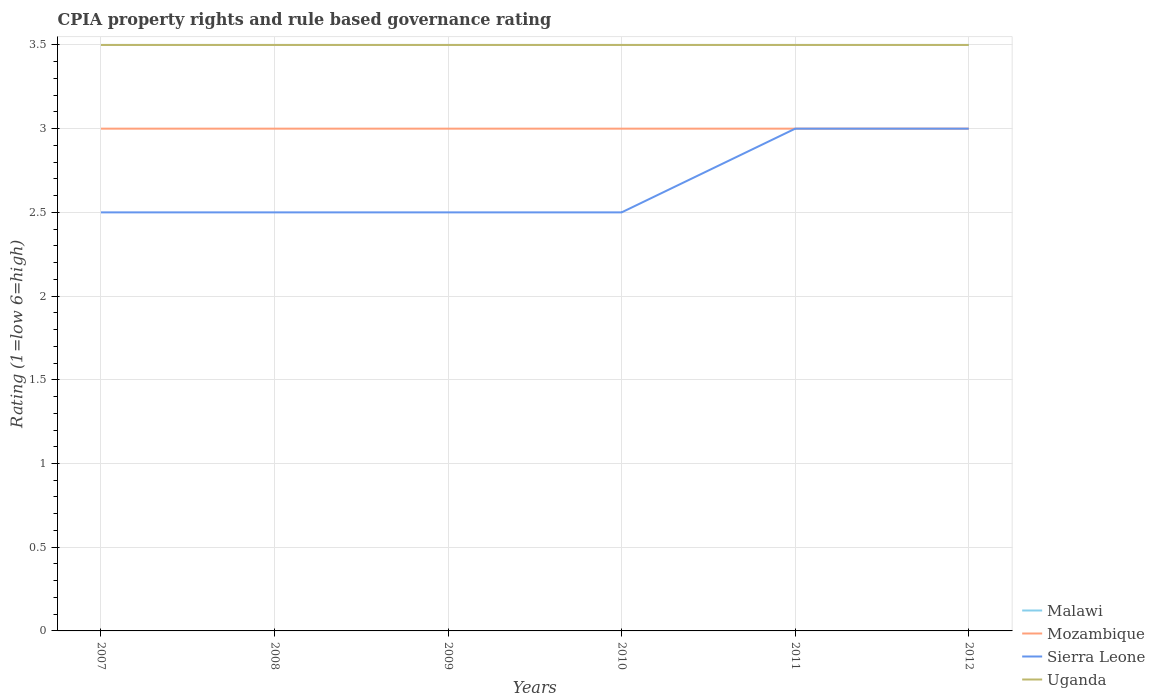Is the number of lines equal to the number of legend labels?
Your answer should be very brief. Yes. Across all years, what is the maximum CPIA rating in Sierra Leone?
Keep it short and to the point. 2.5. In which year was the CPIA rating in Malawi maximum?
Offer a very short reply. 2007. What is the total CPIA rating in Mozambique in the graph?
Give a very brief answer. 0. What is the difference between the highest and the second highest CPIA rating in Uganda?
Offer a very short reply. 0. What is the difference between the highest and the lowest CPIA rating in Mozambique?
Your answer should be compact. 0. Is the CPIA rating in Malawi strictly greater than the CPIA rating in Uganda over the years?
Give a very brief answer. No. What is the difference between two consecutive major ticks on the Y-axis?
Provide a succinct answer. 0.5. Are the values on the major ticks of Y-axis written in scientific E-notation?
Offer a very short reply. No. How many legend labels are there?
Your response must be concise. 4. How are the legend labels stacked?
Keep it short and to the point. Vertical. What is the title of the graph?
Ensure brevity in your answer.  CPIA property rights and rule based governance rating. What is the label or title of the Y-axis?
Ensure brevity in your answer.  Rating (1=low 6=high). What is the Rating (1=low 6=high) in Mozambique in 2007?
Make the answer very short. 3. What is the Rating (1=low 6=high) in Sierra Leone in 2008?
Make the answer very short. 2.5. What is the Rating (1=low 6=high) in Uganda in 2008?
Your response must be concise. 3.5. What is the Rating (1=low 6=high) of Uganda in 2010?
Your answer should be very brief. 3.5. What is the Rating (1=low 6=high) in Malawi in 2012?
Offer a very short reply. 3.5. What is the Rating (1=low 6=high) of Mozambique in 2012?
Your answer should be compact. 3. What is the Rating (1=low 6=high) of Sierra Leone in 2012?
Give a very brief answer. 3. Across all years, what is the maximum Rating (1=low 6=high) of Malawi?
Ensure brevity in your answer.  3.5. Across all years, what is the maximum Rating (1=low 6=high) of Uganda?
Provide a succinct answer. 3.5. Across all years, what is the minimum Rating (1=low 6=high) in Mozambique?
Give a very brief answer. 3. What is the total Rating (1=low 6=high) of Malawi in the graph?
Offer a very short reply. 21. What is the total Rating (1=low 6=high) in Mozambique in the graph?
Provide a short and direct response. 18. What is the total Rating (1=low 6=high) in Sierra Leone in the graph?
Ensure brevity in your answer.  16. What is the difference between the Rating (1=low 6=high) of Malawi in 2007 and that in 2008?
Provide a short and direct response. 0. What is the difference between the Rating (1=low 6=high) in Mozambique in 2007 and that in 2008?
Offer a terse response. 0. What is the difference between the Rating (1=low 6=high) in Malawi in 2007 and that in 2009?
Your answer should be compact. 0. What is the difference between the Rating (1=low 6=high) of Mozambique in 2007 and that in 2009?
Provide a short and direct response. 0. What is the difference between the Rating (1=low 6=high) of Uganda in 2007 and that in 2009?
Your answer should be very brief. 0. What is the difference between the Rating (1=low 6=high) of Malawi in 2007 and that in 2010?
Ensure brevity in your answer.  0. What is the difference between the Rating (1=low 6=high) of Mozambique in 2007 and that in 2010?
Provide a short and direct response. 0. What is the difference between the Rating (1=low 6=high) in Sierra Leone in 2007 and that in 2010?
Keep it short and to the point. 0. What is the difference between the Rating (1=low 6=high) of Malawi in 2007 and that in 2011?
Provide a short and direct response. 0. What is the difference between the Rating (1=low 6=high) of Mozambique in 2007 and that in 2011?
Make the answer very short. 0. What is the difference between the Rating (1=low 6=high) in Sierra Leone in 2007 and that in 2011?
Your answer should be compact. -0.5. What is the difference between the Rating (1=low 6=high) in Uganda in 2007 and that in 2011?
Your answer should be very brief. 0. What is the difference between the Rating (1=low 6=high) of Malawi in 2007 and that in 2012?
Your response must be concise. 0. What is the difference between the Rating (1=low 6=high) of Mozambique in 2007 and that in 2012?
Your answer should be compact. 0. What is the difference between the Rating (1=low 6=high) of Uganda in 2007 and that in 2012?
Offer a very short reply. 0. What is the difference between the Rating (1=low 6=high) in Sierra Leone in 2008 and that in 2009?
Ensure brevity in your answer.  0. What is the difference between the Rating (1=low 6=high) in Mozambique in 2008 and that in 2010?
Offer a very short reply. 0. What is the difference between the Rating (1=low 6=high) of Sierra Leone in 2008 and that in 2010?
Provide a short and direct response. 0. What is the difference between the Rating (1=low 6=high) of Mozambique in 2008 and that in 2011?
Provide a succinct answer. 0. What is the difference between the Rating (1=low 6=high) in Malawi in 2008 and that in 2012?
Offer a terse response. 0. What is the difference between the Rating (1=low 6=high) in Uganda in 2009 and that in 2010?
Provide a succinct answer. 0. What is the difference between the Rating (1=low 6=high) of Malawi in 2009 and that in 2011?
Provide a succinct answer. 0. What is the difference between the Rating (1=low 6=high) of Sierra Leone in 2009 and that in 2011?
Your answer should be very brief. -0.5. What is the difference between the Rating (1=low 6=high) of Mozambique in 2009 and that in 2012?
Give a very brief answer. 0. What is the difference between the Rating (1=low 6=high) of Malawi in 2010 and that in 2011?
Keep it short and to the point. 0. What is the difference between the Rating (1=low 6=high) of Sierra Leone in 2010 and that in 2011?
Give a very brief answer. -0.5. What is the difference between the Rating (1=low 6=high) of Mozambique in 2010 and that in 2012?
Your response must be concise. 0. What is the difference between the Rating (1=low 6=high) of Uganda in 2010 and that in 2012?
Keep it short and to the point. 0. What is the difference between the Rating (1=low 6=high) in Malawi in 2011 and that in 2012?
Keep it short and to the point. 0. What is the difference between the Rating (1=low 6=high) of Sierra Leone in 2011 and that in 2012?
Ensure brevity in your answer.  0. What is the difference between the Rating (1=low 6=high) of Malawi in 2007 and the Rating (1=low 6=high) of Mozambique in 2008?
Ensure brevity in your answer.  0.5. What is the difference between the Rating (1=low 6=high) of Malawi in 2007 and the Rating (1=low 6=high) of Uganda in 2008?
Provide a succinct answer. 0. What is the difference between the Rating (1=low 6=high) in Mozambique in 2007 and the Rating (1=low 6=high) in Sierra Leone in 2008?
Provide a short and direct response. 0.5. What is the difference between the Rating (1=low 6=high) in Sierra Leone in 2007 and the Rating (1=low 6=high) in Uganda in 2008?
Ensure brevity in your answer.  -1. What is the difference between the Rating (1=low 6=high) of Malawi in 2007 and the Rating (1=low 6=high) of Mozambique in 2009?
Your answer should be very brief. 0.5. What is the difference between the Rating (1=low 6=high) in Mozambique in 2007 and the Rating (1=low 6=high) in Sierra Leone in 2009?
Provide a short and direct response. 0.5. What is the difference between the Rating (1=low 6=high) of Mozambique in 2007 and the Rating (1=low 6=high) of Uganda in 2009?
Keep it short and to the point. -0.5. What is the difference between the Rating (1=low 6=high) of Malawi in 2007 and the Rating (1=low 6=high) of Mozambique in 2010?
Your answer should be very brief. 0.5. What is the difference between the Rating (1=low 6=high) in Sierra Leone in 2007 and the Rating (1=low 6=high) in Uganda in 2010?
Your answer should be very brief. -1. What is the difference between the Rating (1=low 6=high) of Malawi in 2007 and the Rating (1=low 6=high) of Mozambique in 2011?
Offer a terse response. 0.5. What is the difference between the Rating (1=low 6=high) of Malawi in 2007 and the Rating (1=low 6=high) of Uganda in 2011?
Make the answer very short. 0. What is the difference between the Rating (1=low 6=high) in Mozambique in 2007 and the Rating (1=low 6=high) in Sierra Leone in 2011?
Provide a succinct answer. 0. What is the difference between the Rating (1=low 6=high) of Sierra Leone in 2007 and the Rating (1=low 6=high) of Uganda in 2011?
Your answer should be very brief. -1. What is the difference between the Rating (1=low 6=high) in Malawi in 2008 and the Rating (1=low 6=high) in Uganda in 2009?
Provide a short and direct response. 0. What is the difference between the Rating (1=low 6=high) in Mozambique in 2008 and the Rating (1=low 6=high) in Sierra Leone in 2009?
Ensure brevity in your answer.  0.5. What is the difference between the Rating (1=low 6=high) in Sierra Leone in 2008 and the Rating (1=low 6=high) in Uganda in 2009?
Ensure brevity in your answer.  -1. What is the difference between the Rating (1=low 6=high) in Mozambique in 2008 and the Rating (1=low 6=high) in Uganda in 2010?
Offer a terse response. -0.5. What is the difference between the Rating (1=low 6=high) in Sierra Leone in 2008 and the Rating (1=low 6=high) in Uganda in 2010?
Give a very brief answer. -1. What is the difference between the Rating (1=low 6=high) of Malawi in 2008 and the Rating (1=low 6=high) of Mozambique in 2011?
Provide a succinct answer. 0.5. What is the difference between the Rating (1=low 6=high) of Malawi in 2008 and the Rating (1=low 6=high) of Sierra Leone in 2011?
Provide a succinct answer. 0.5. What is the difference between the Rating (1=low 6=high) of Malawi in 2008 and the Rating (1=low 6=high) of Uganda in 2011?
Your response must be concise. 0. What is the difference between the Rating (1=low 6=high) of Mozambique in 2008 and the Rating (1=low 6=high) of Uganda in 2011?
Make the answer very short. -0.5. What is the difference between the Rating (1=low 6=high) of Malawi in 2008 and the Rating (1=low 6=high) of Sierra Leone in 2012?
Provide a succinct answer. 0.5. What is the difference between the Rating (1=low 6=high) in Malawi in 2008 and the Rating (1=low 6=high) in Uganda in 2012?
Your answer should be compact. 0. What is the difference between the Rating (1=low 6=high) of Mozambique in 2008 and the Rating (1=low 6=high) of Sierra Leone in 2012?
Your answer should be compact. 0. What is the difference between the Rating (1=low 6=high) of Mozambique in 2008 and the Rating (1=low 6=high) of Uganda in 2012?
Give a very brief answer. -0.5. What is the difference between the Rating (1=low 6=high) in Malawi in 2009 and the Rating (1=low 6=high) in Mozambique in 2010?
Make the answer very short. 0.5. What is the difference between the Rating (1=low 6=high) of Malawi in 2009 and the Rating (1=low 6=high) of Sierra Leone in 2010?
Provide a short and direct response. 1. What is the difference between the Rating (1=low 6=high) in Malawi in 2009 and the Rating (1=low 6=high) in Uganda in 2010?
Your answer should be compact. 0. What is the difference between the Rating (1=low 6=high) of Mozambique in 2009 and the Rating (1=low 6=high) of Sierra Leone in 2010?
Give a very brief answer. 0.5. What is the difference between the Rating (1=low 6=high) in Mozambique in 2009 and the Rating (1=low 6=high) in Sierra Leone in 2011?
Your answer should be very brief. 0. What is the difference between the Rating (1=low 6=high) in Malawi in 2009 and the Rating (1=low 6=high) in Mozambique in 2012?
Offer a terse response. 0.5. What is the difference between the Rating (1=low 6=high) of Mozambique in 2009 and the Rating (1=low 6=high) of Sierra Leone in 2012?
Provide a succinct answer. 0. What is the difference between the Rating (1=low 6=high) in Malawi in 2010 and the Rating (1=low 6=high) in Sierra Leone in 2011?
Your answer should be compact. 0.5. What is the difference between the Rating (1=low 6=high) of Malawi in 2010 and the Rating (1=low 6=high) of Uganda in 2012?
Offer a very short reply. 0. What is the difference between the Rating (1=low 6=high) in Mozambique in 2010 and the Rating (1=low 6=high) in Sierra Leone in 2012?
Ensure brevity in your answer.  0. What is the difference between the Rating (1=low 6=high) in Malawi in 2011 and the Rating (1=low 6=high) in Mozambique in 2012?
Provide a succinct answer. 0.5. What is the difference between the Rating (1=low 6=high) of Malawi in 2011 and the Rating (1=low 6=high) of Uganda in 2012?
Your response must be concise. 0. What is the difference between the Rating (1=low 6=high) of Mozambique in 2011 and the Rating (1=low 6=high) of Uganda in 2012?
Provide a succinct answer. -0.5. What is the average Rating (1=low 6=high) in Sierra Leone per year?
Provide a succinct answer. 2.67. What is the average Rating (1=low 6=high) of Uganda per year?
Keep it short and to the point. 3.5. In the year 2007, what is the difference between the Rating (1=low 6=high) in Malawi and Rating (1=low 6=high) in Sierra Leone?
Provide a short and direct response. 1. In the year 2007, what is the difference between the Rating (1=low 6=high) of Mozambique and Rating (1=low 6=high) of Sierra Leone?
Ensure brevity in your answer.  0.5. In the year 2007, what is the difference between the Rating (1=low 6=high) in Sierra Leone and Rating (1=low 6=high) in Uganda?
Keep it short and to the point. -1. In the year 2008, what is the difference between the Rating (1=low 6=high) in Malawi and Rating (1=low 6=high) in Mozambique?
Your response must be concise. 0.5. In the year 2008, what is the difference between the Rating (1=low 6=high) of Mozambique and Rating (1=low 6=high) of Sierra Leone?
Provide a short and direct response. 0.5. In the year 2009, what is the difference between the Rating (1=low 6=high) in Malawi and Rating (1=low 6=high) in Sierra Leone?
Give a very brief answer. 1. In the year 2009, what is the difference between the Rating (1=low 6=high) in Mozambique and Rating (1=low 6=high) in Uganda?
Make the answer very short. -0.5. In the year 2010, what is the difference between the Rating (1=low 6=high) of Malawi and Rating (1=low 6=high) of Mozambique?
Provide a succinct answer. 0.5. In the year 2010, what is the difference between the Rating (1=low 6=high) in Malawi and Rating (1=low 6=high) in Sierra Leone?
Give a very brief answer. 1. In the year 2010, what is the difference between the Rating (1=low 6=high) of Malawi and Rating (1=low 6=high) of Uganda?
Provide a succinct answer. 0. In the year 2010, what is the difference between the Rating (1=low 6=high) of Mozambique and Rating (1=low 6=high) of Uganda?
Provide a succinct answer. -0.5. In the year 2011, what is the difference between the Rating (1=low 6=high) in Malawi and Rating (1=low 6=high) in Mozambique?
Offer a very short reply. 0.5. In the year 2011, what is the difference between the Rating (1=low 6=high) in Malawi and Rating (1=low 6=high) in Uganda?
Your response must be concise. 0. In the year 2011, what is the difference between the Rating (1=low 6=high) of Mozambique and Rating (1=low 6=high) of Uganda?
Give a very brief answer. -0.5. In the year 2012, what is the difference between the Rating (1=low 6=high) of Malawi and Rating (1=low 6=high) of Sierra Leone?
Your answer should be compact. 0.5. In the year 2012, what is the difference between the Rating (1=low 6=high) of Mozambique and Rating (1=low 6=high) of Sierra Leone?
Offer a terse response. 0. In the year 2012, what is the difference between the Rating (1=low 6=high) in Mozambique and Rating (1=low 6=high) in Uganda?
Offer a terse response. -0.5. In the year 2012, what is the difference between the Rating (1=low 6=high) in Sierra Leone and Rating (1=low 6=high) in Uganda?
Provide a short and direct response. -0.5. What is the ratio of the Rating (1=low 6=high) of Malawi in 2007 to that in 2008?
Ensure brevity in your answer.  1. What is the ratio of the Rating (1=low 6=high) of Uganda in 2007 to that in 2008?
Provide a succinct answer. 1. What is the ratio of the Rating (1=low 6=high) in Mozambique in 2007 to that in 2009?
Your answer should be compact. 1. What is the ratio of the Rating (1=low 6=high) of Uganda in 2007 to that in 2009?
Keep it short and to the point. 1. What is the ratio of the Rating (1=low 6=high) of Malawi in 2007 to that in 2010?
Offer a very short reply. 1. What is the ratio of the Rating (1=low 6=high) in Malawi in 2007 to that in 2012?
Keep it short and to the point. 1. What is the ratio of the Rating (1=low 6=high) in Sierra Leone in 2007 to that in 2012?
Keep it short and to the point. 0.83. What is the ratio of the Rating (1=low 6=high) in Uganda in 2007 to that in 2012?
Your answer should be very brief. 1. What is the ratio of the Rating (1=low 6=high) of Sierra Leone in 2008 to that in 2009?
Ensure brevity in your answer.  1. What is the ratio of the Rating (1=low 6=high) in Malawi in 2008 to that in 2010?
Offer a terse response. 1. What is the ratio of the Rating (1=low 6=high) in Malawi in 2008 to that in 2011?
Your answer should be compact. 1. What is the ratio of the Rating (1=low 6=high) in Mozambique in 2008 to that in 2011?
Provide a succinct answer. 1. What is the ratio of the Rating (1=low 6=high) of Uganda in 2008 to that in 2011?
Give a very brief answer. 1. What is the ratio of the Rating (1=low 6=high) in Sierra Leone in 2008 to that in 2012?
Your response must be concise. 0.83. What is the ratio of the Rating (1=low 6=high) of Malawi in 2009 to that in 2010?
Give a very brief answer. 1. What is the ratio of the Rating (1=low 6=high) of Sierra Leone in 2009 to that in 2011?
Your answer should be very brief. 0.83. What is the ratio of the Rating (1=low 6=high) in Uganda in 2009 to that in 2011?
Your answer should be compact. 1. What is the ratio of the Rating (1=low 6=high) in Mozambique in 2009 to that in 2012?
Your response must be concise. 1. What is the ratio of the Rating (1=low 6=high) in Mozambique in 2010 to that in 2011?
Provide a succinct answer. 1. What is the ratio of the Rating (1=low 6=high) in Mozambique in 2010 to that in 2012?
Offer a very short reply. 1. What is the ratio of the Rating (1=low 6=high) of Sierra Leone in 2010 to that in 2012?
Make the answer very short. 0.83. What is the ratio of the Rating (1=low 6=high) in Uganda in 2010 to that in 2012?
Offer a very short reply. 1. What is the ratio of the Rating (1=low 6=high) of Malawi in 2011 to that in 2012?
Offer a very short reply. 1. What is the ratio of the Rating (1=low 6=high) in Mozambique in 2011 to that in 2012?
Provide a short and direct response. 1. What is the ratio of the Rating (1=low 6=high) in Sierra Leone in 2011 to that in 2012?
Make the answer very short. 1. What is the difference between the highest and the second highest Rating (1=low 6=high) in Mozambique?
Ensure brevity in your answer.  0. What is the difference between the highest and the second highest Rating (1=low 6=high) of Uganda?
Give a very brief answer. 0. What is the difference between the highest and the lowest Rating (1=low 6=high) of Mozambique?
Offer a terse response. 0. What is the difference between the highest and the lowest Rating (1=low 6=high) in Sierra Leone?
Keep it short and to the point. 0.5. What is the difference between the highest and the lowest Rating (1=low 6=high) of Uganda?
Your answer should be compact. 0. 